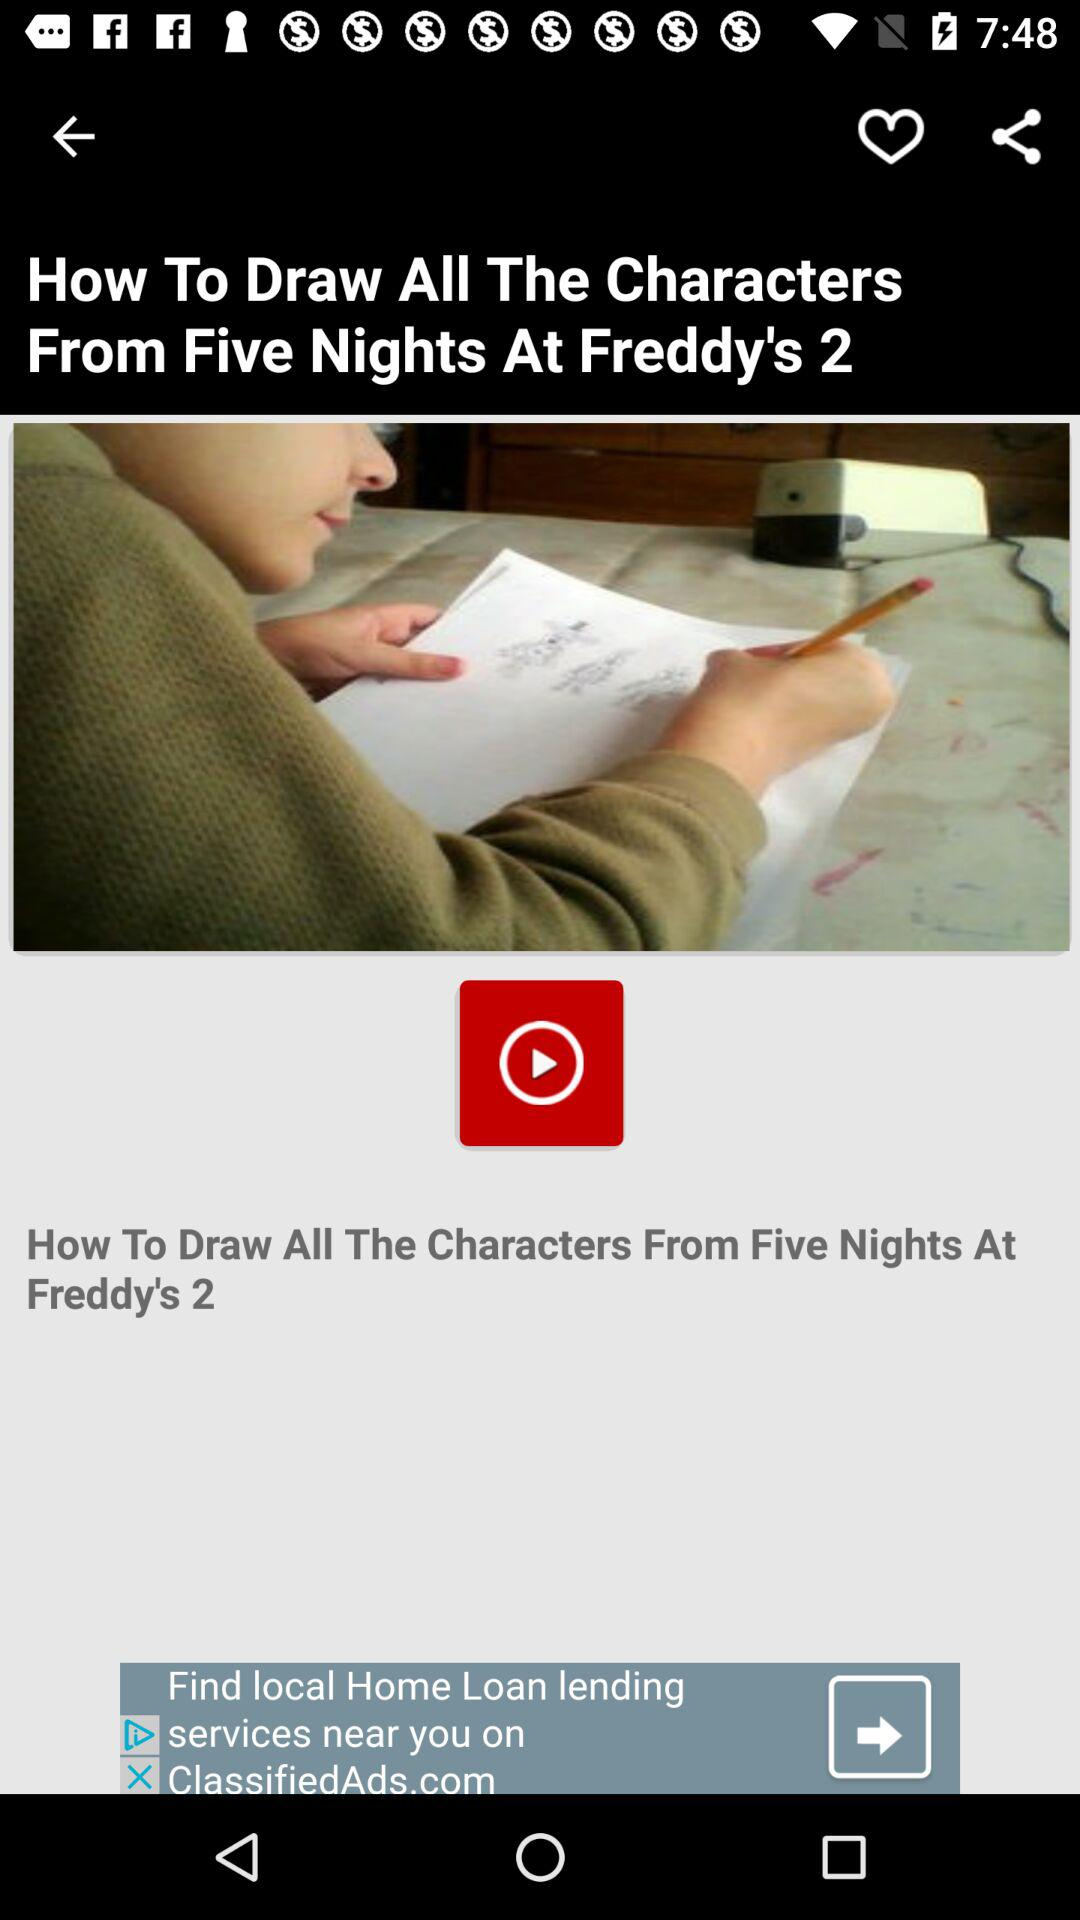What is the title? The title is "How To Draw All The Characters From Five Nights At Freddy's 2". 